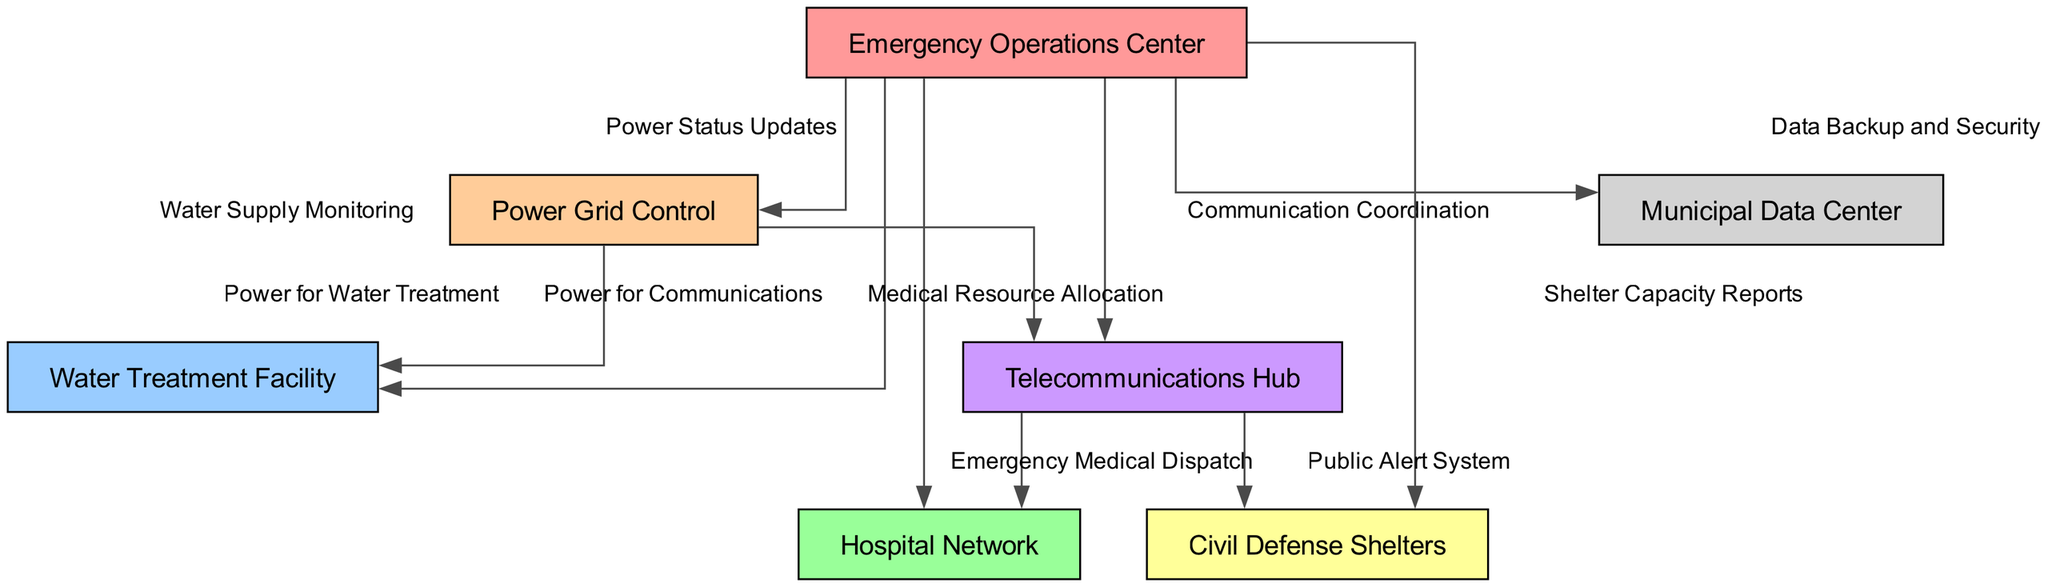What is the main function of the Emergency Operations Center? The diagram indicates that the Emergency Operations Center is the central hub that coordinates various emergency responses, including updates on power, water supply, communication, medical resources, shelter capacities, and data security.
Answer: Coordination How many nodes are in the diagram? By counting the nodes listed in the diagram, there are a total of seven nodes representing different critical infrastructure components.
Answer: Seven Which node is responsible for emergency medical dispatch? The Telecommunications Hub connects to the Hospital Network, and through this edge, it is indicated that it provides emergency medical dispatch services.
Answer: Telecommunications Hub What type of reports does the Emergency Operations Center receive from Civil Defense Shelters? The diagram shows that the Emergency Operations Center receives shelter capacity reports from Civil Defense Shelters, which indicates the status of the shelters during a crisis.
Answer: Shelter Capacity Reports What relationship exists between the Power Grid Control and the Water Treatment Facility? The diagram illustrates that there is a direct relationship where Power Grid Control provides power to the Water Treatment Facility, indicating a dependency for operational capacity.
Answer: Power for Water Treatment What information does the Telecommunications Hub provide to the Emergency Operations Center? The Telecommunications Hub supplies communication coordination updates to the Emergency Operations Center, facilitating the overall management of emergency responses.
Answer: Communication Coordination Which node provides data backup and security to the Emergency Operations Center? The Municipal Data Center is responsible for providing data backup and security to the Emergency Operations Center as shown in the connections.
Answer: Municipal Data Center What are the two functions linked to the Telecommunications Hub? The Telecommunications Hub connects to both the Hospital Network for emergency medical dispatch and the Civil Defense Shelters for the public alert system, indicating its dual role in communication.
Answer: Emergency Medical Dispatch and Public Alert System How does Power Grid Control contribute to the operation of telecommunications? The diagram indicates that Power Grid Control supplies power to the Telecommunications Hub, thus enabling its operation during a crisis situation.
Answer: Power for Communications 